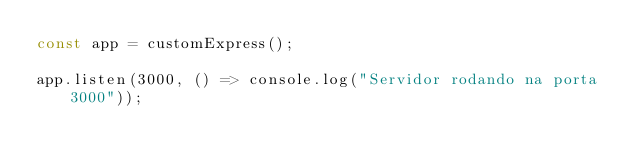Convert code to text. <code><loc_0><loc_0><loc_500><loc_500><_JavaScript_>const app = customExpress();

app.listen(3000, () => console.log("Servidor rodando na porta 3000"));
</code> 